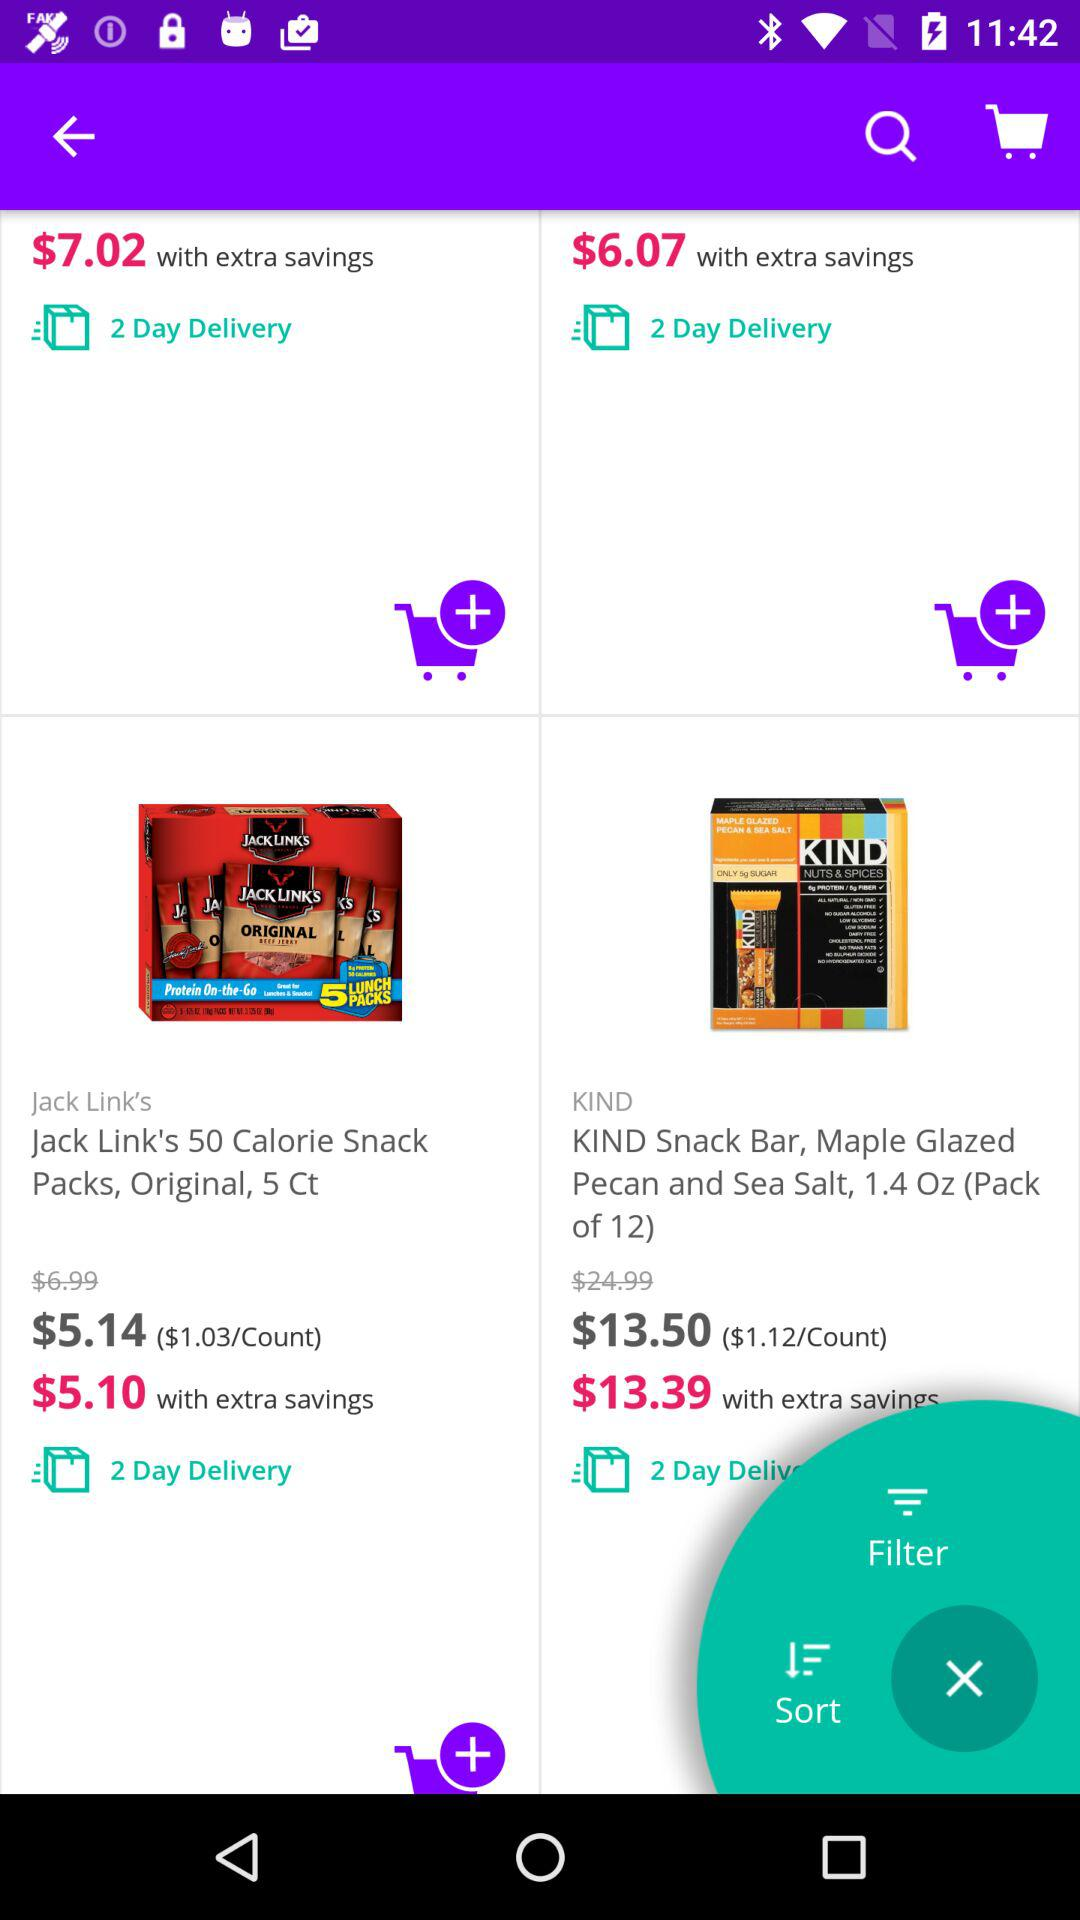What is the extra saving price of "KIND snack bar, Maple Glazed Pecan and Sea Salt, 1.4 Oz (Pack of 12)"? The extra saving price of "KIND snack bar, Maple Glazed Pecan and Sea Salt, 1.4 Oz (Pack of 12)" is 13.39 dollars. 